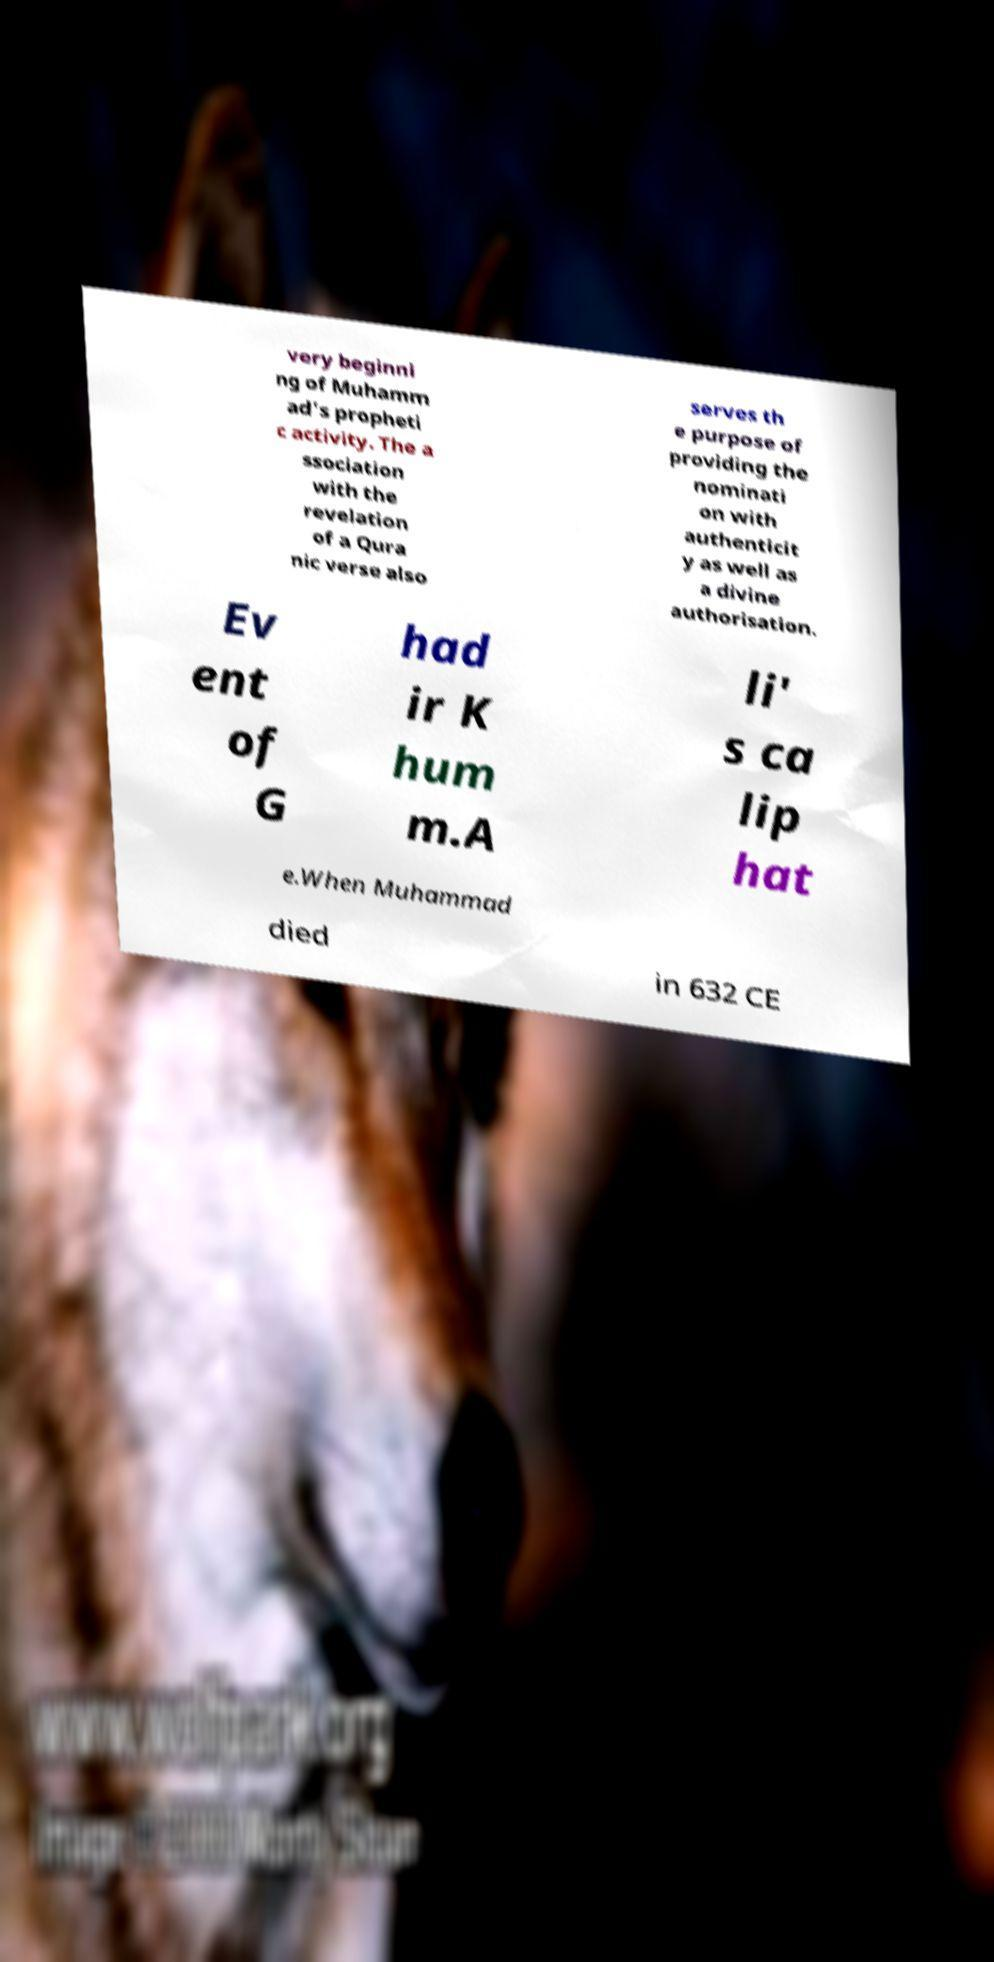Please identify and transcribe the text found in this image. very beginni ng of Muhamm ad's propheti c activity. The a ssociation with the revelation of a Qura nic verse also serves th e purpose of providing the nominati on with authenticit y as well as a divine authorisation. Ev ent of G had ir K hum m.A li' s ca lip hat e.When Muhammad died in 632 CE 